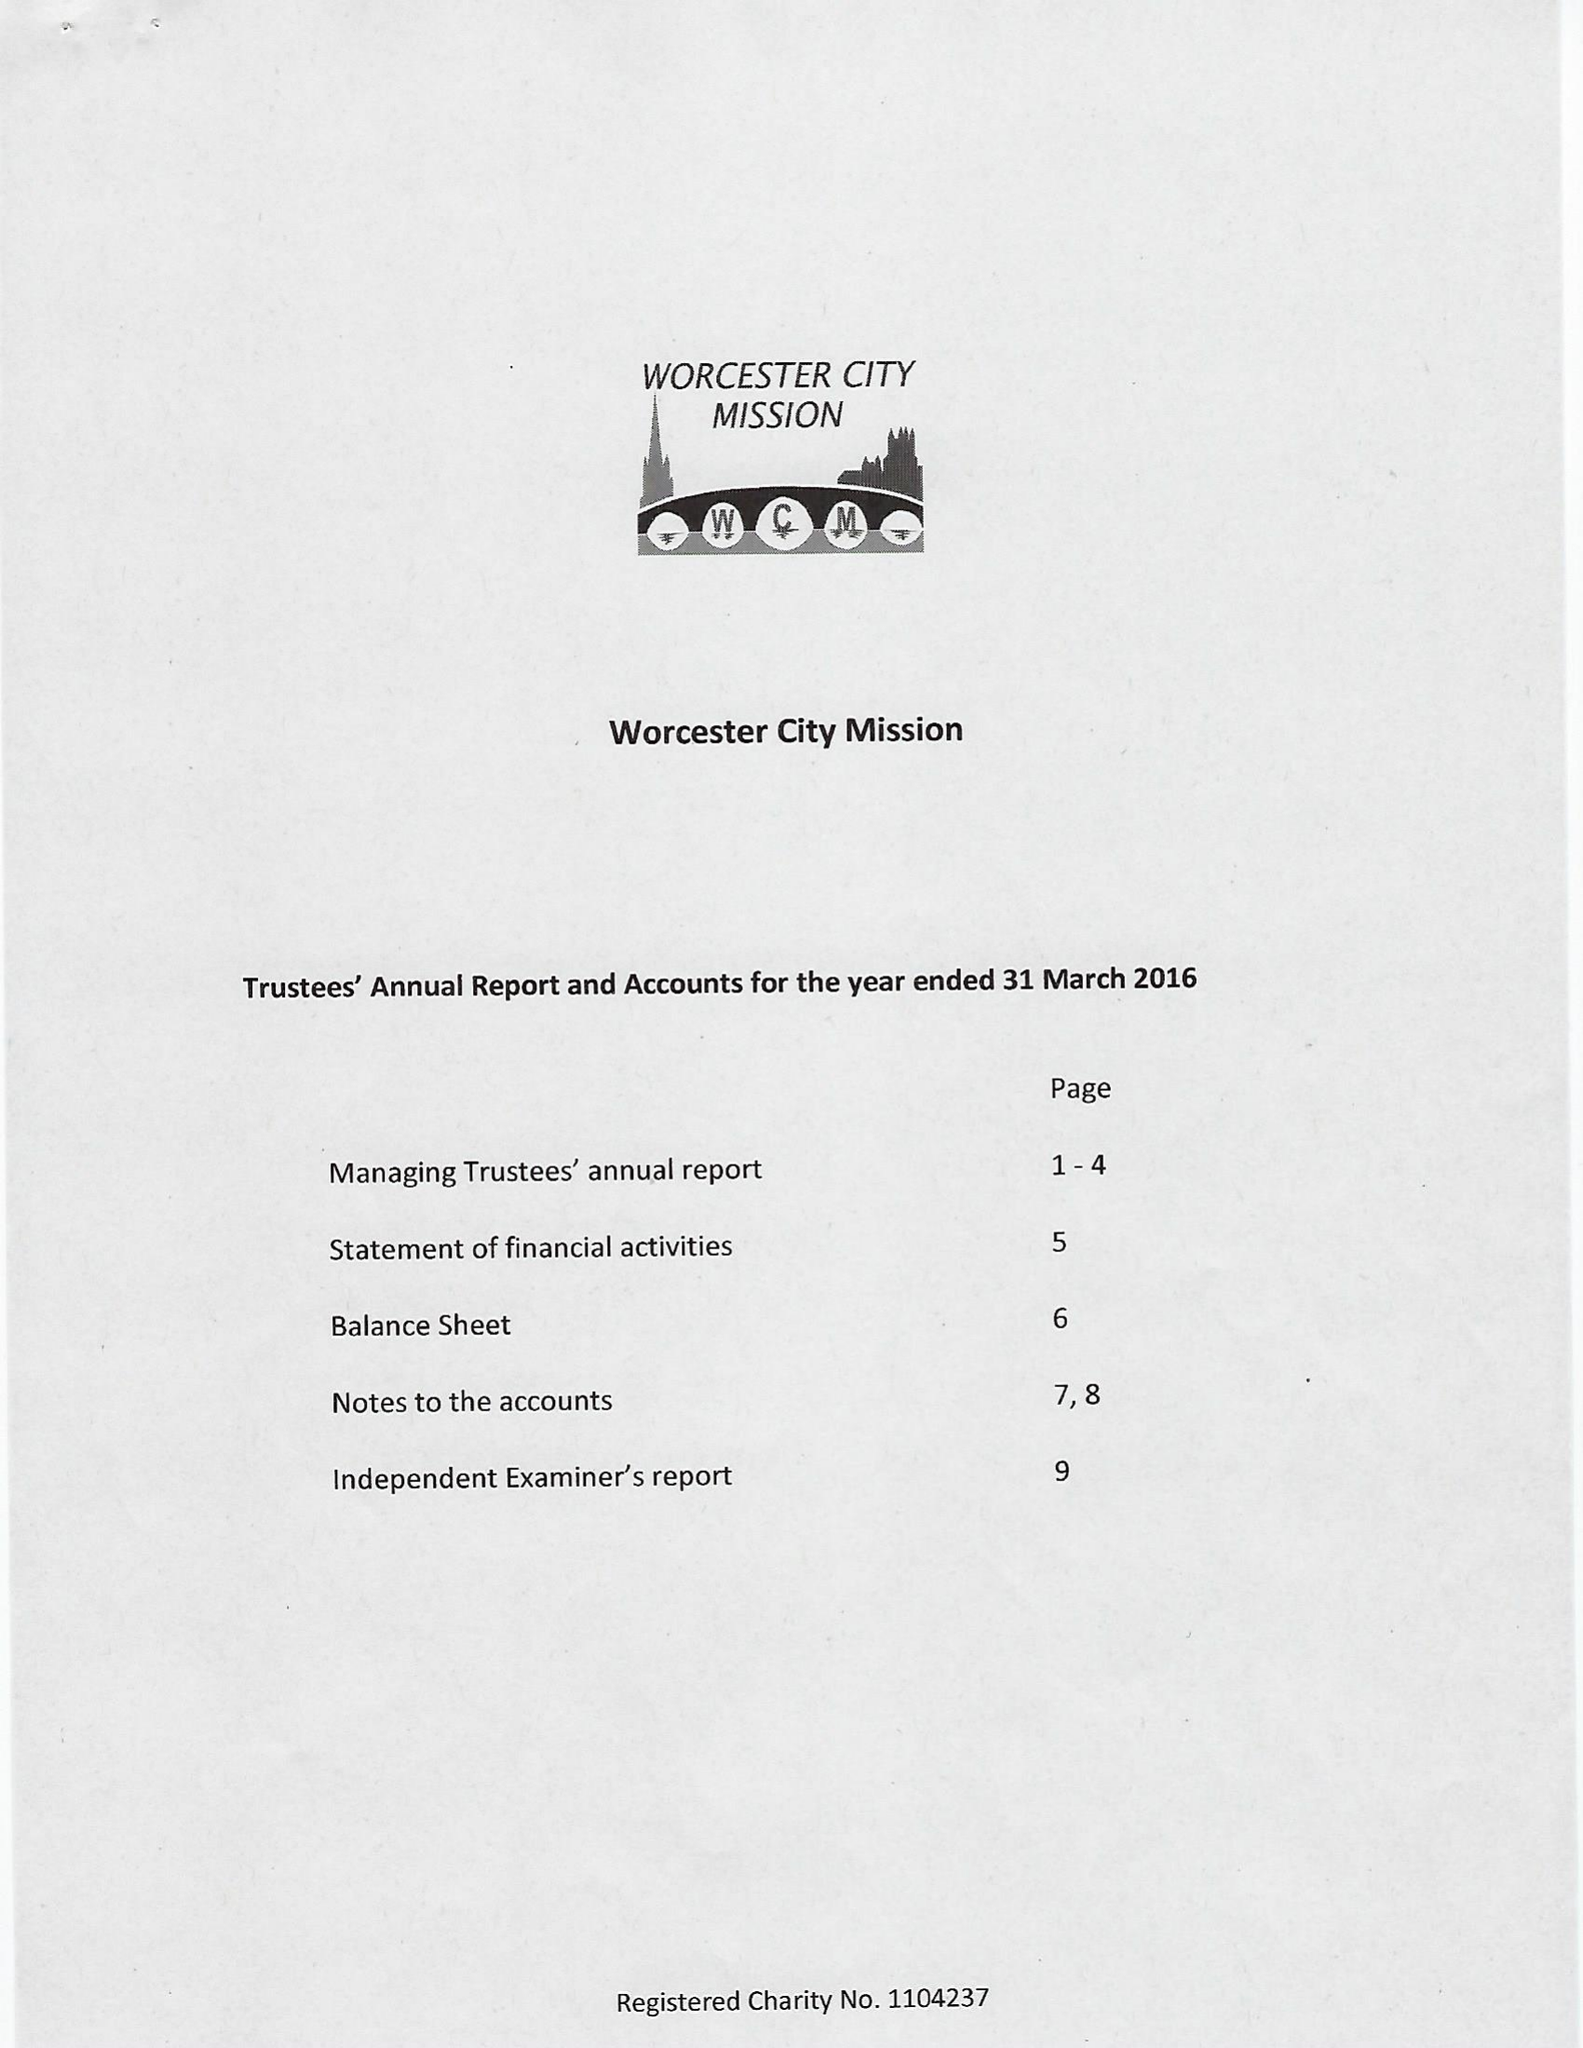What is the value for the income_annually_in_british_pounds?
Answer the question using a single word or phrase. 49676.00 